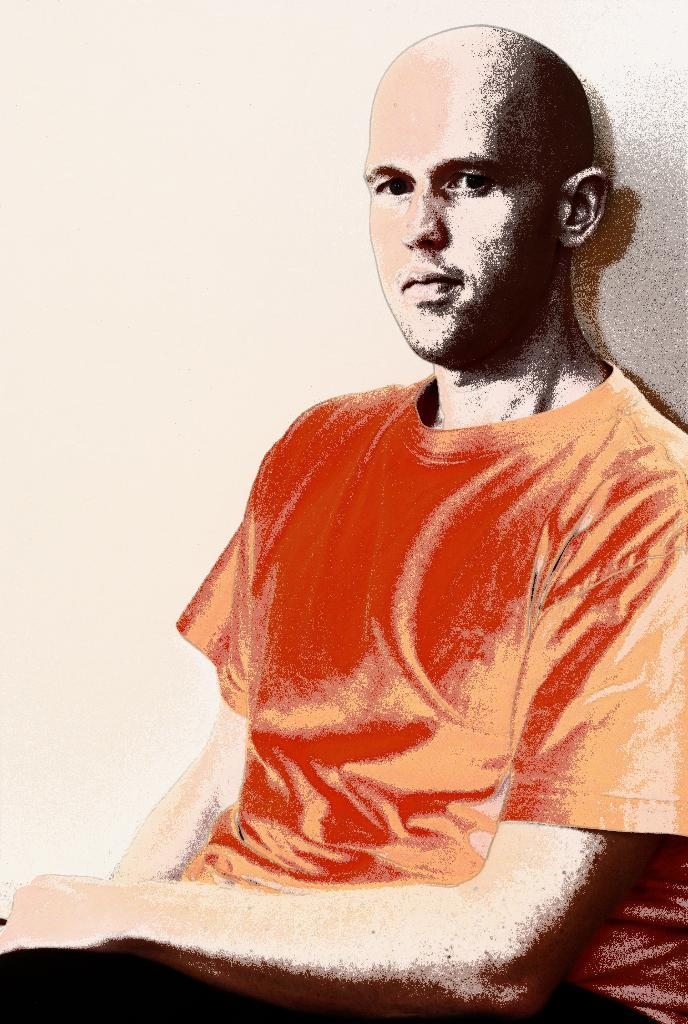What is the main subject of the image? There is a person in the image. What color is the shirt the person is wearing? The person is wearing an orange shirt. What color are the pants the person is wearing? The person is wearing black pants. What is a distinctive feature of the person's appearance? The person has a bald head. What type of apple can be seen growing on the side of the person in the image? There is no apple or indication of a plant growing on the person in the image. What is the person doing with the mailbox in the image? There is no mailbox present in the image. 